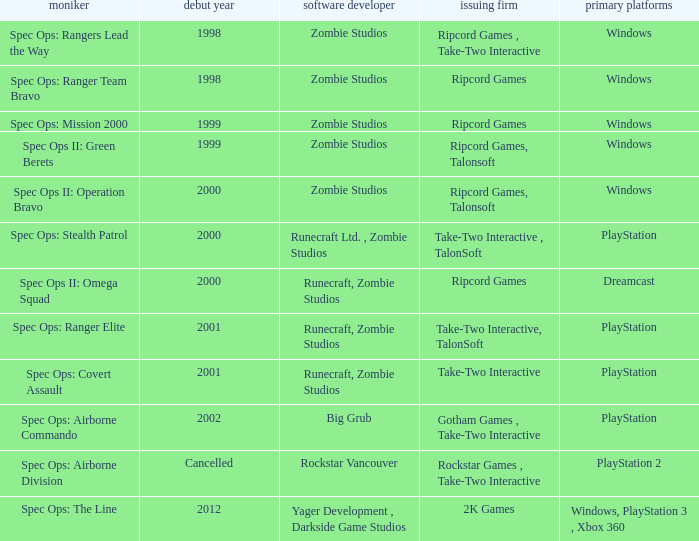Which developer has a year of cancelled releases? Rockstar Vancouver. 